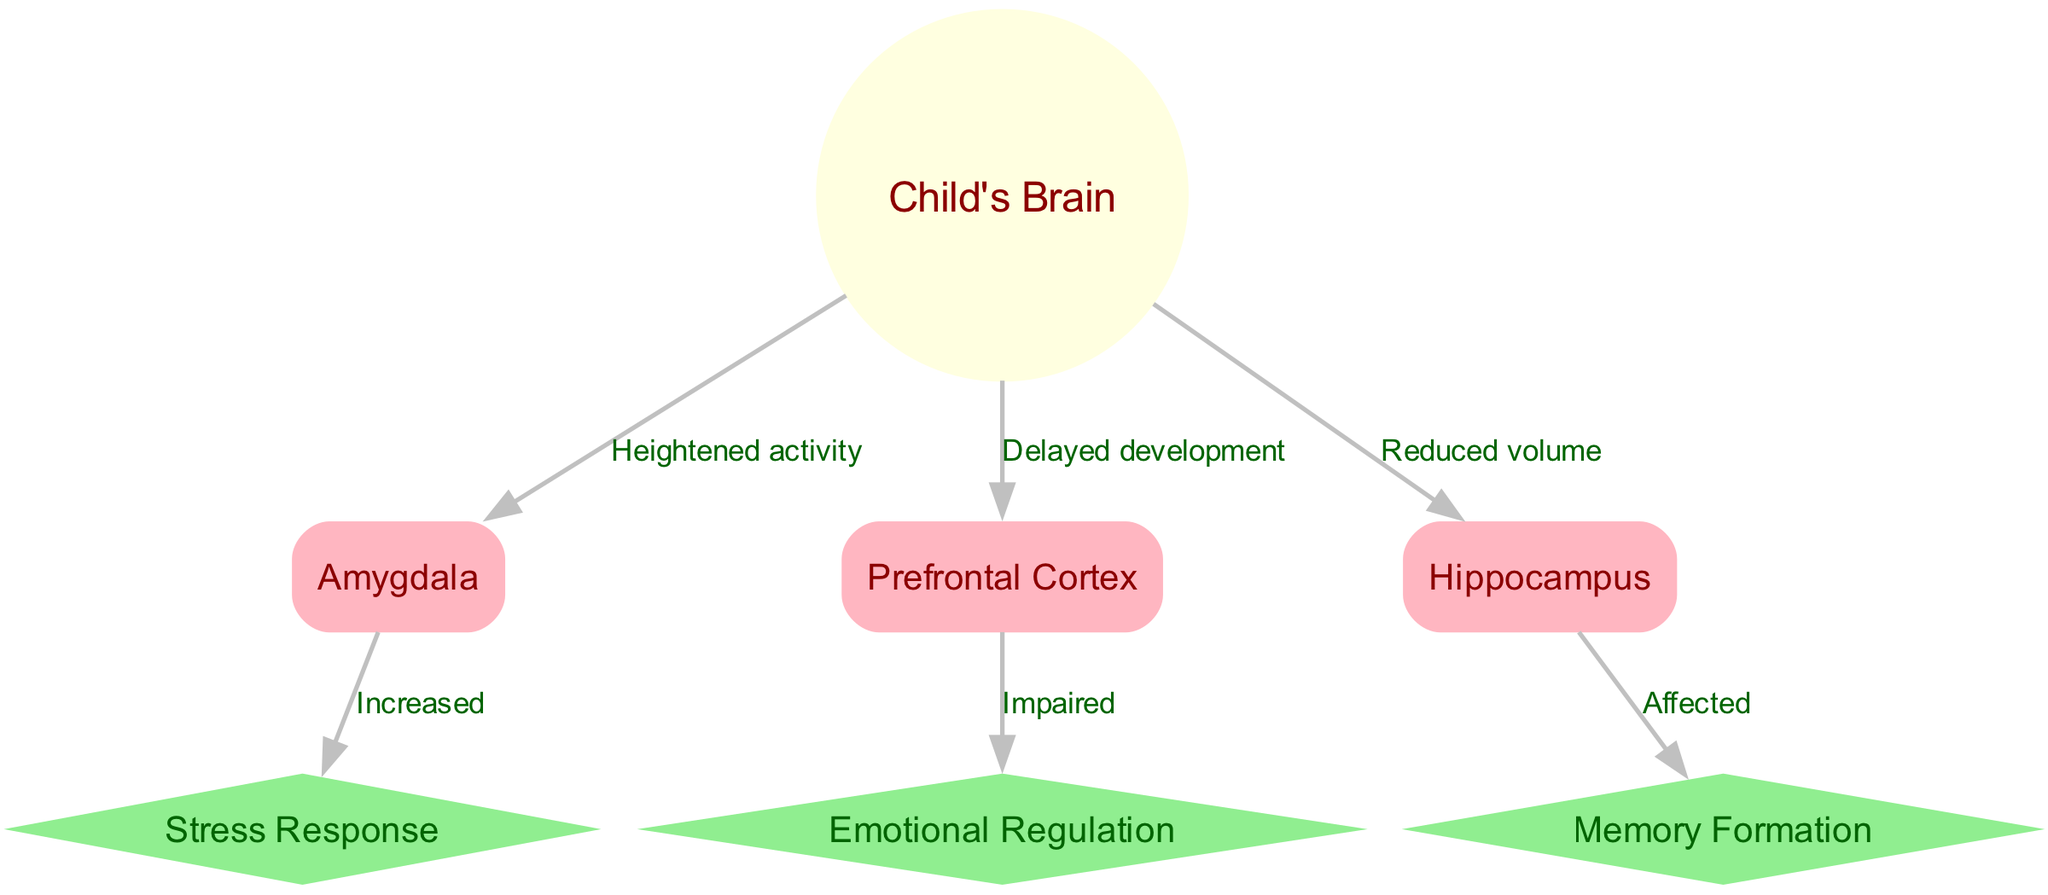What is the central node in the diagram? The central node is identified as "Child's Brain," which is represented as a circle in the diagram. It is the primary subject from which other nodes branch out, illustrating its central role in the depiction of children's brain development.
Answer: Child's Brain How many nodes are present in the diagram? To find the total number of nodes, we can count each distinct entry in the "nodes" section of the data provided. There are seven nodes in total: Child's Brain, Amygdala, Prefrontal Cortex, Hippocampus, Stress Response, Emotional Regulation, and Memory Formation.
Answer: 7 What effect does the amygdala have on the stress response? The edge connecting the "Amygdala" and "Stress Response" nodes indicates an "Increased" relationship, meaning that the activity or development of the amygdala leads to heightened stress responses.
Answer: Increased Which area of the brain shows a delayed development? The diagram indicates that the "Prefrontal Cortex" is associated with "Delayed development," as stated in the edge connecting these two nodes. This illustrates the impact of divorce-related psychological effects on this specific brain area.
Answer: Prefrontal Cortex What does the hippocampus affect in terms of brain function? The edge shows a direct connection from the "Hippocampus" to "Memory Formation," labeled as "Affected." This signifies that the hippocampus plays a crucial role in the ability to form memories, which can be compromised due to psychological effects.
Answer: Memory Formation Which area is linked to emotional regulation and how? The diagram highlights that the "Prefrontal Cortex" is "Impaired" in terms of emotional regulation, indicated by the edge connecting these two nodes. This means that its development impairment affects the child’s ability to manage emotions.
Answer: Impaired What is the relationship between the hippocampus and its volume? The diagram indicates a "Reduced volume" for the "Hippocampus," suggesting that the changes in the child's brain due to psychological effects can lead to a decrease in the size of this important area.
Answer: Reduced volume How does heightened activity in the amygdala influence the child's stress response? The connection between "Amygdala" and "Stress Response" suggests a direct link where increased activity in the amygdala leads to an increase in the child's stress response, highlighting the impact of emotional stimuli.
Answer: Increased 